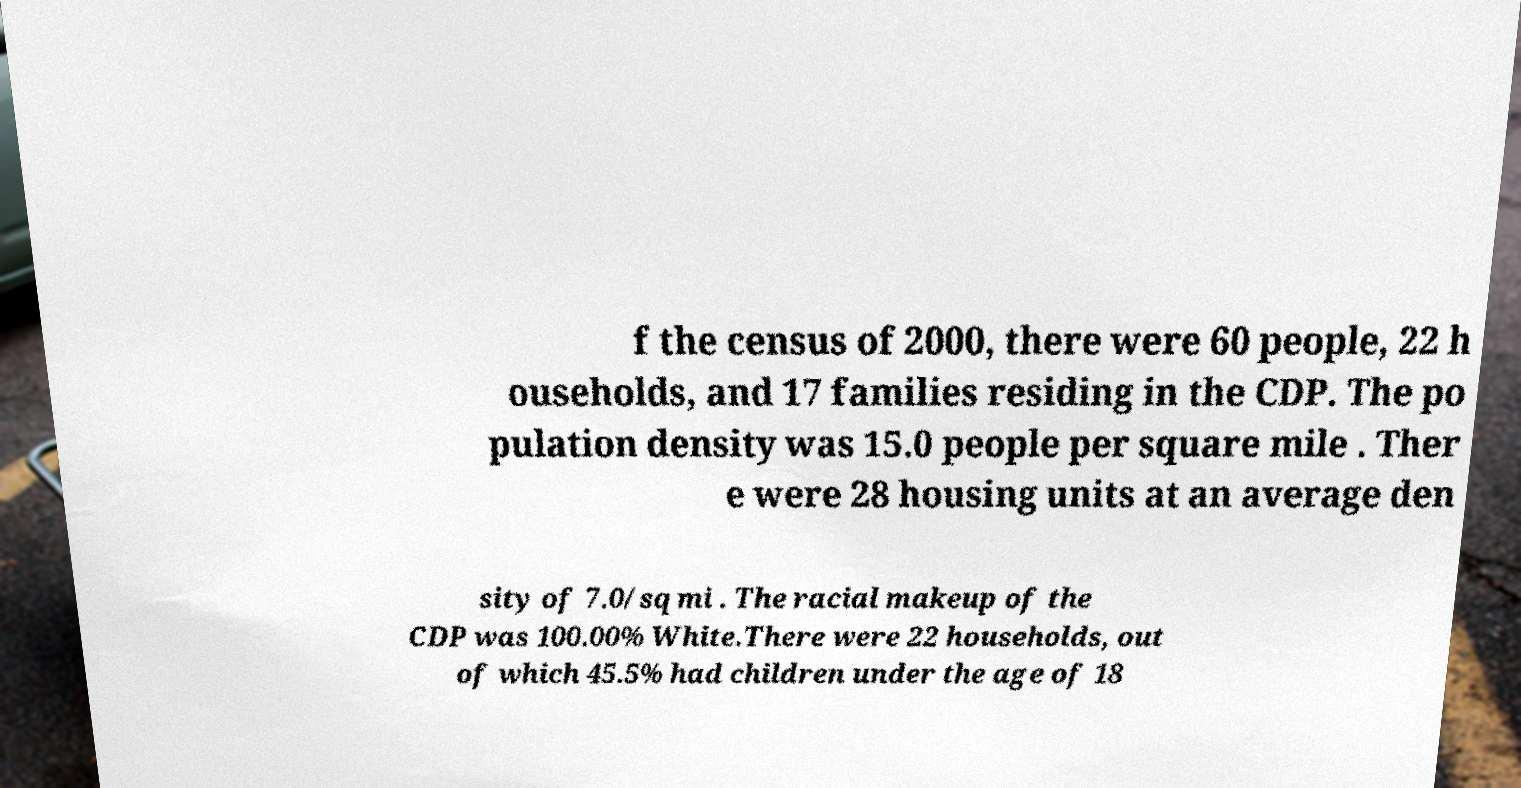For documentation purposes, I need the text within this image transcribed. Could you provide that? f the census of 2000, there were 60 people, 22 h ouseholds, and 17 families residing in the CDP. The po pulation density was 15.0 people per square mile . Ther e were 28 housing units at an average den sity of 7.0/sq mi . The racial makeup of the CDP was 100.00% White.There were 22 households, out of which 45.5% had children under the age of 18 